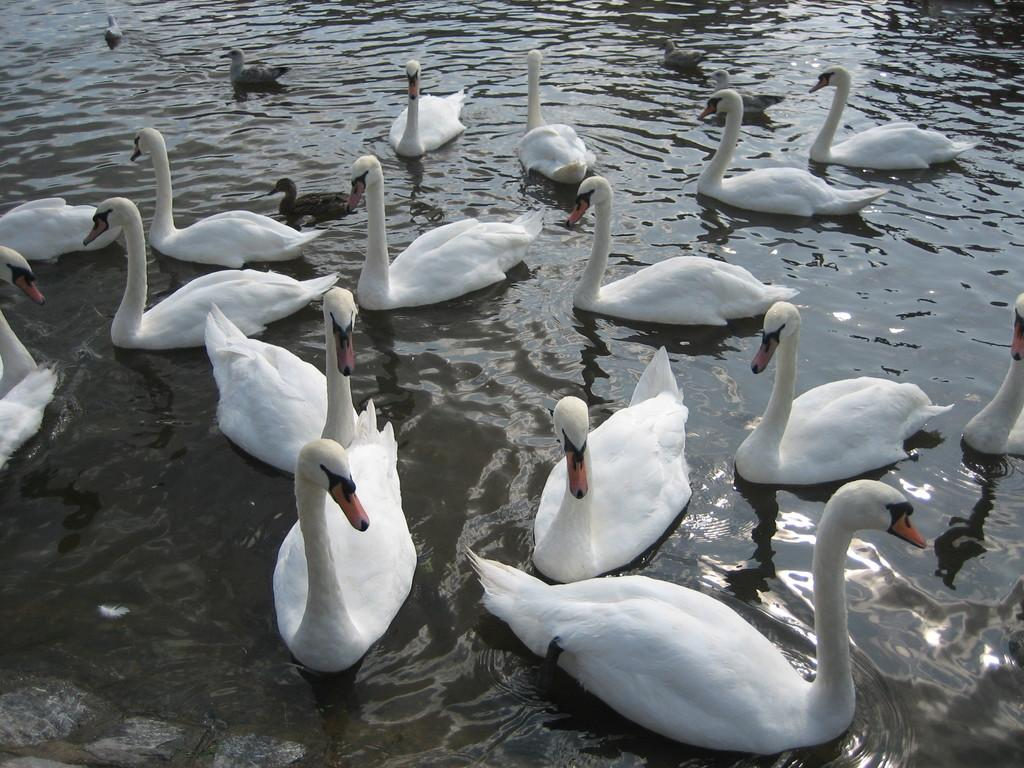What type of animals are in the image? There are swans in the image. What color are the swans? The swans are white in color. What are the swans doing in the image? The swans are swimming in the water. Are there any other birds in the image? Yes, there are two black birds in the water on the left side of the image. Where is the lunchroom located in the image? There is no lunchroom present in the image; it features swans swimming in the water. What type of nose can be seen on the swans in the image? Swans do not have noses like humans; they have beaks, which are not mentioned in the image. 